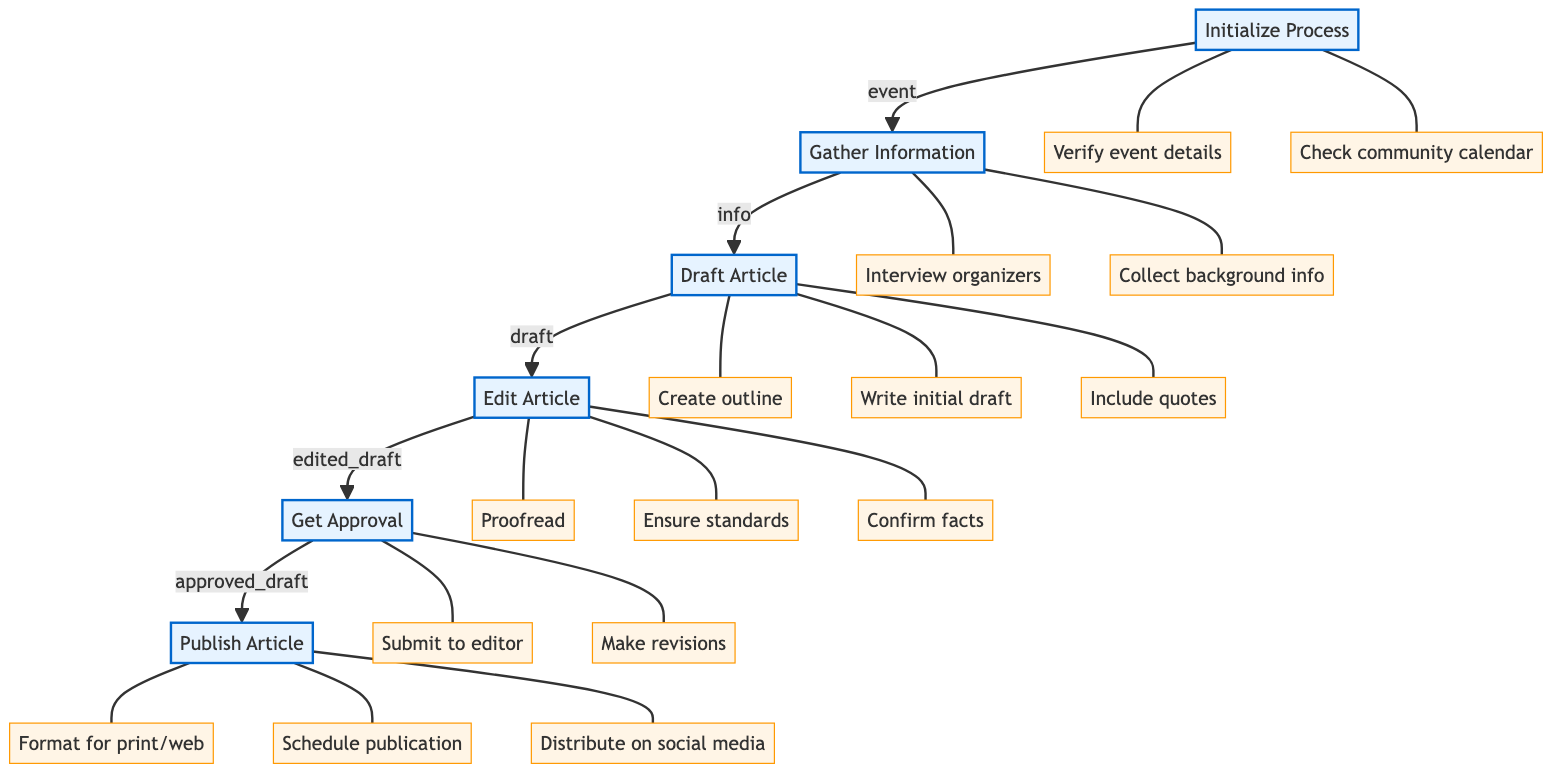What is the starting point of the publication process? From the diagram, the first step that initiates the publication process is labeled "Initialize Process." It indicates the process will begin from this node before moving to the next step.
Answer: Initialize Process How many tasks are involved in drafting the article? In the diagram, the "Draft Article" step has three associated tasks: creating an outline, writing an initial draft, and including quotes. Counting these gives a total of three tasks for this process.
Answer: Three Which step follows after gathering information? The flowchart indicates that after "Gather Information," the next step that is taken is "Draft Article." This shows a direct transition from one to the next in the process flow.
Answer: Draft Article What task is related to proofreading in the article editing phase? The diagram indicates "Proofread" as one of the tasks under the "Edit Article" step. This signifies that proofreading is a crucial part of editing the drafted article.
Answer: Proofread What is the purpose of the "Get Approval" step? The "Get Approval" step serves as a checkpoint where the edited draft is submitted to the senior editor. It is meant for obtaining necessary revisions based on feedback, indicating its role in the quality control of the article.
Answer: Submit article to senior editor What is the last action taken in the publication process? According to the flowchart, the final action is "Distribute article through social media channels," which shows the last step of the process focusing on sharing the published article.
Answer: Distribute article through social media channels Which task involves confirming facts and figures? The task that involves this activity is labeled "Confirm facts" within the "Edit Article" phase. This is essential to ensure the accuracy of the published information.
Answer: Confirm facts How many steps are there in total in the publication process? By counting the distinct process steps in the diagram: Initialize Process, Gather Information, Draft Article, Edit Article, Get Approval, and Publish Article, we see there are a total of six steps in the publication process.
Answer: Six Which function corresponds to the draft article process? The function associated with the task of drafting the article is labeled "def draft_article(info):" in the diagram. This highlights the specific programming function that pertains to this stage.
Answer: def draft_article(info): 